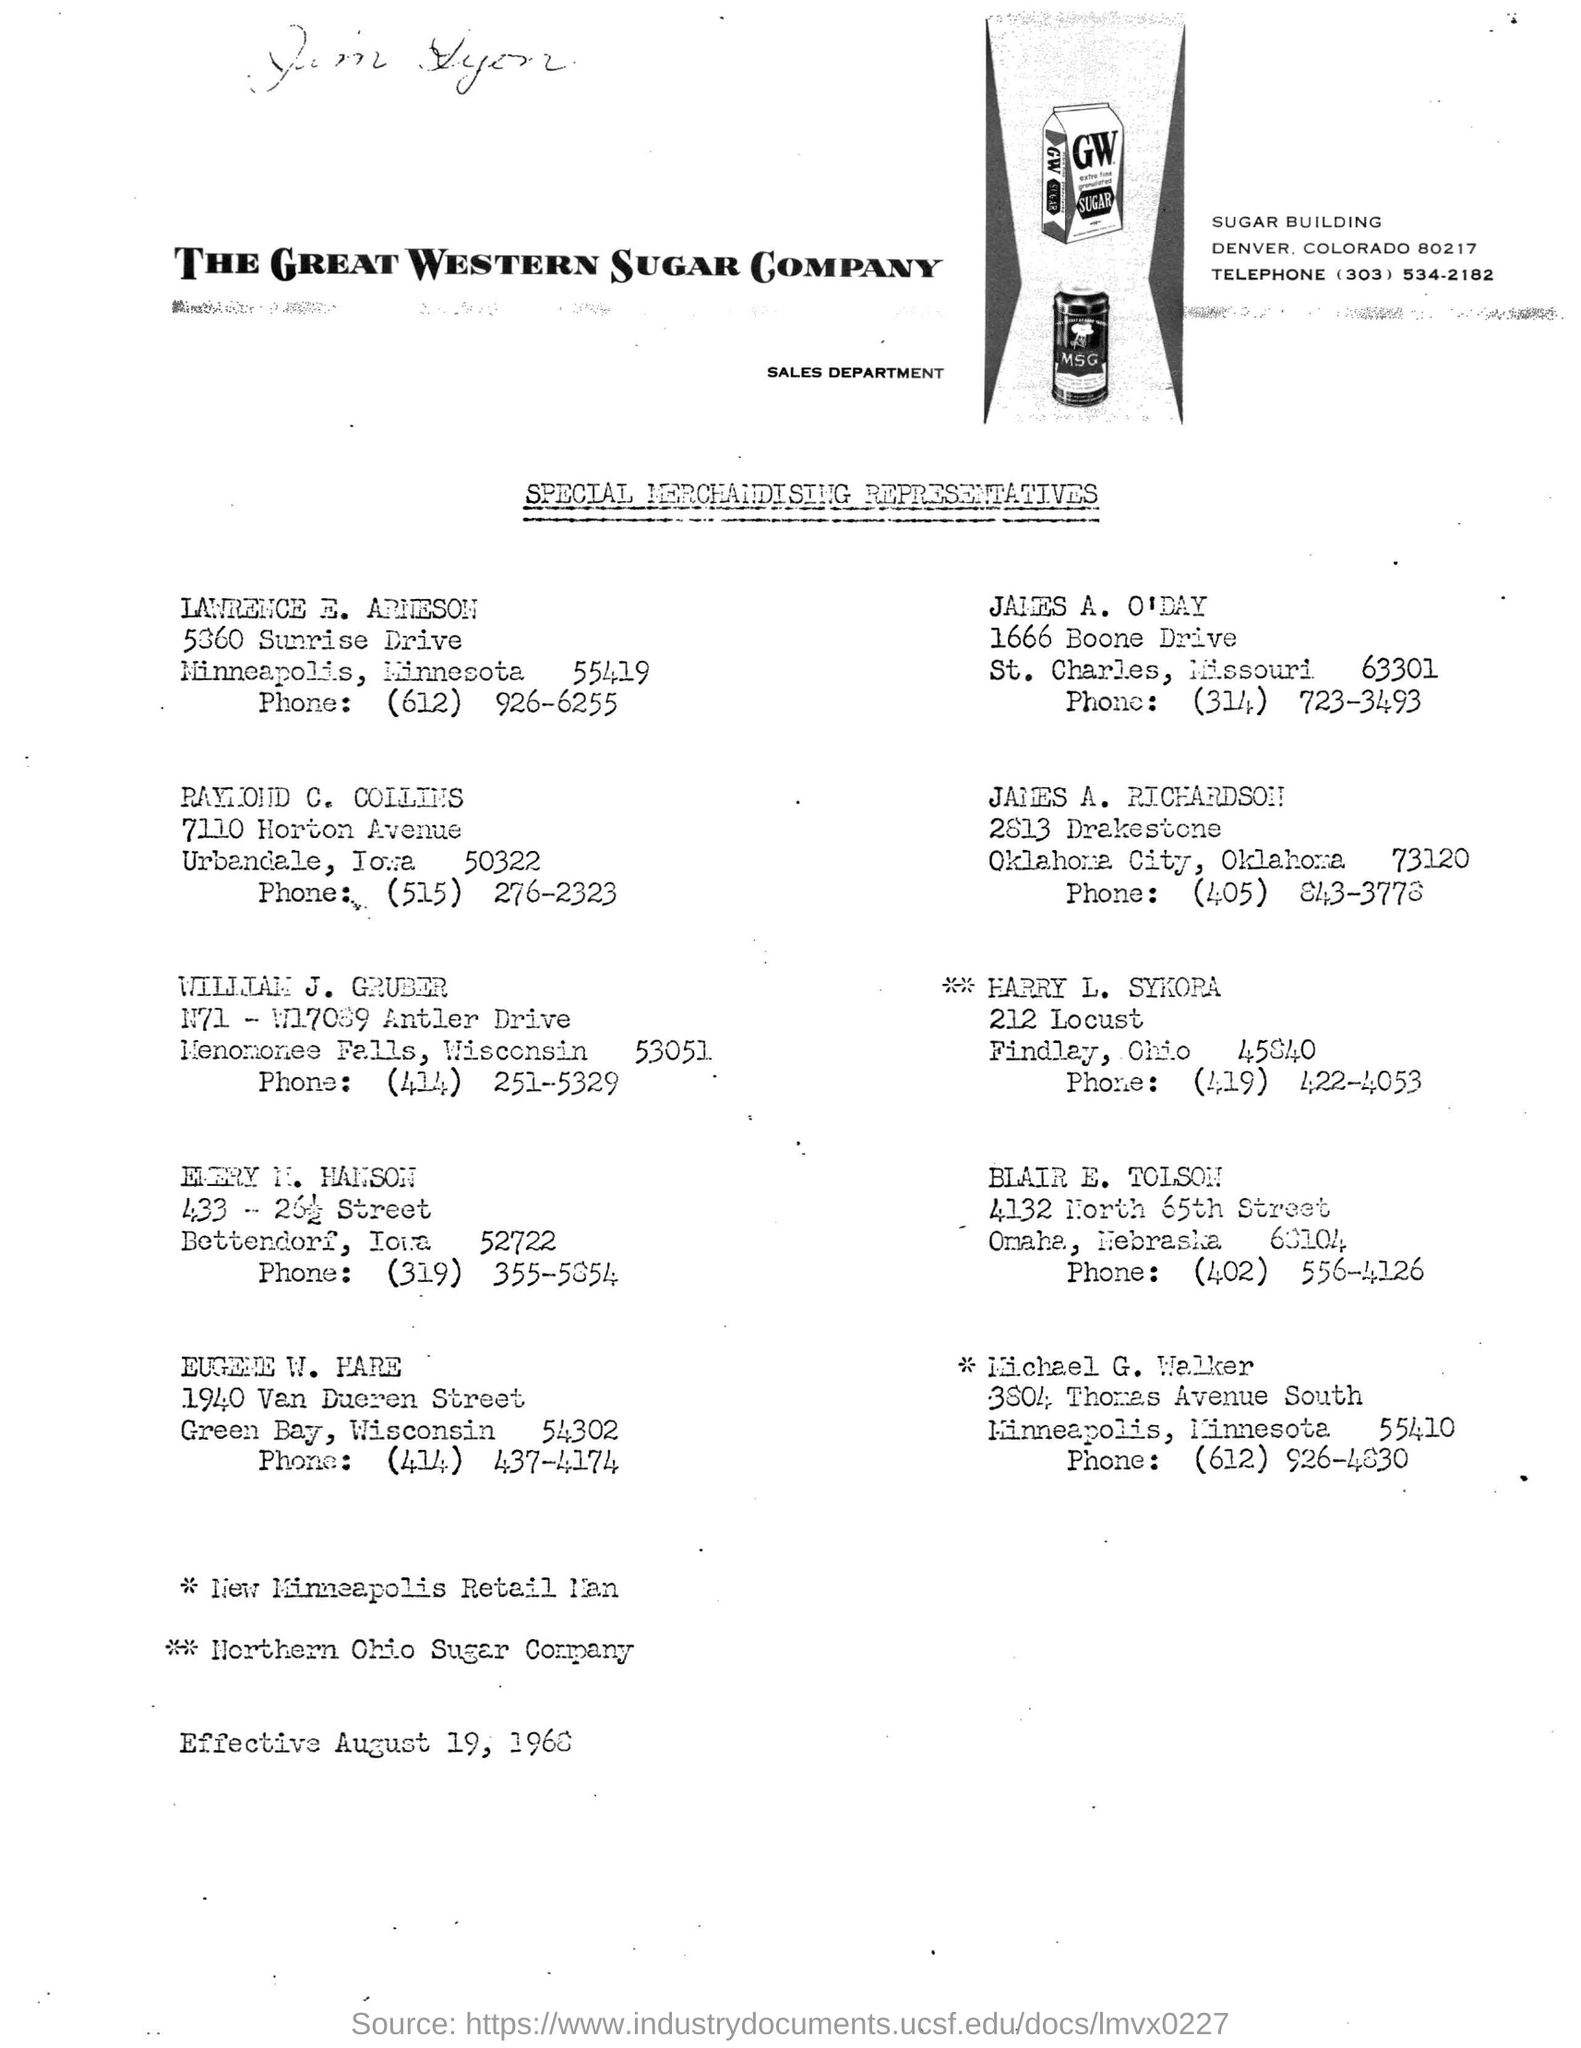Outline some significant characteristics in this image. The Great Western Sugar Company is the name of the company mentioned. The department mentioned is named Sales. The name of the building mentioned is Sugar. 